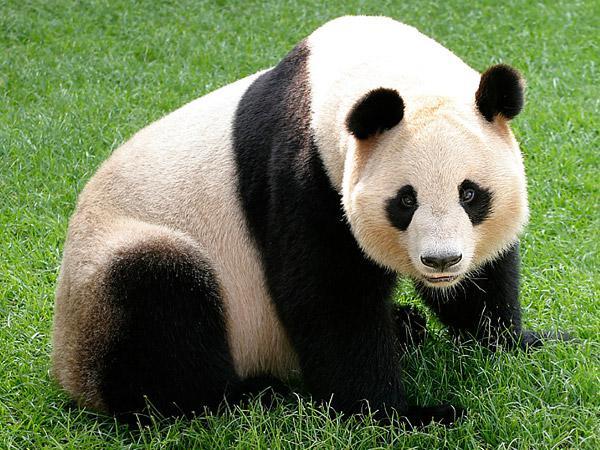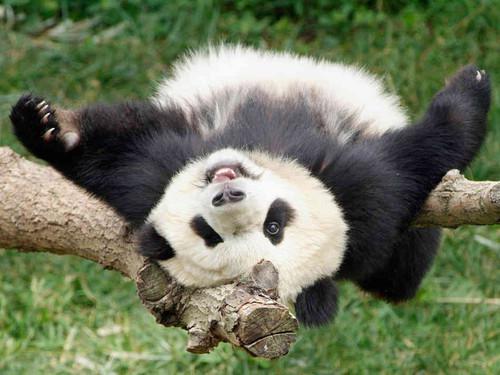The first image is the image on the left, the second image is the image on the right. For the images shown, is this caption "One image shows a panda at play." true? Answer yes or no. Yes. The first image is the image on the left, the second image is the image on the right. For the images displayed, is the sentence "A panda is eating bamboo." factually correct? Answer yes or no. No. The first image is the image on the left, the second image is the image on the right. Analyze the images presented: Is the assertion "Panda in the right image is nibbling something." valid? Answer yes or no. No. The first image is the image on the left, the second image is the image on the right. Assess this claim about the two images: "A panda has both front paws wrapped around something that is more round than stick-shaped.". Correct or not? Answer yes or no. No. The first image is the image on the left, the second image is the image on the right. For the images shown, is this caption "An image shows a panda munching on a branch." true? Answer yes or no. No. The first image is the image on the left, the second image is the image on the right. Examine the images to the left and right. Is the description "There is a single panda sitting in the grass in the image on the left." accurate? Answer yes or no. Yes. 